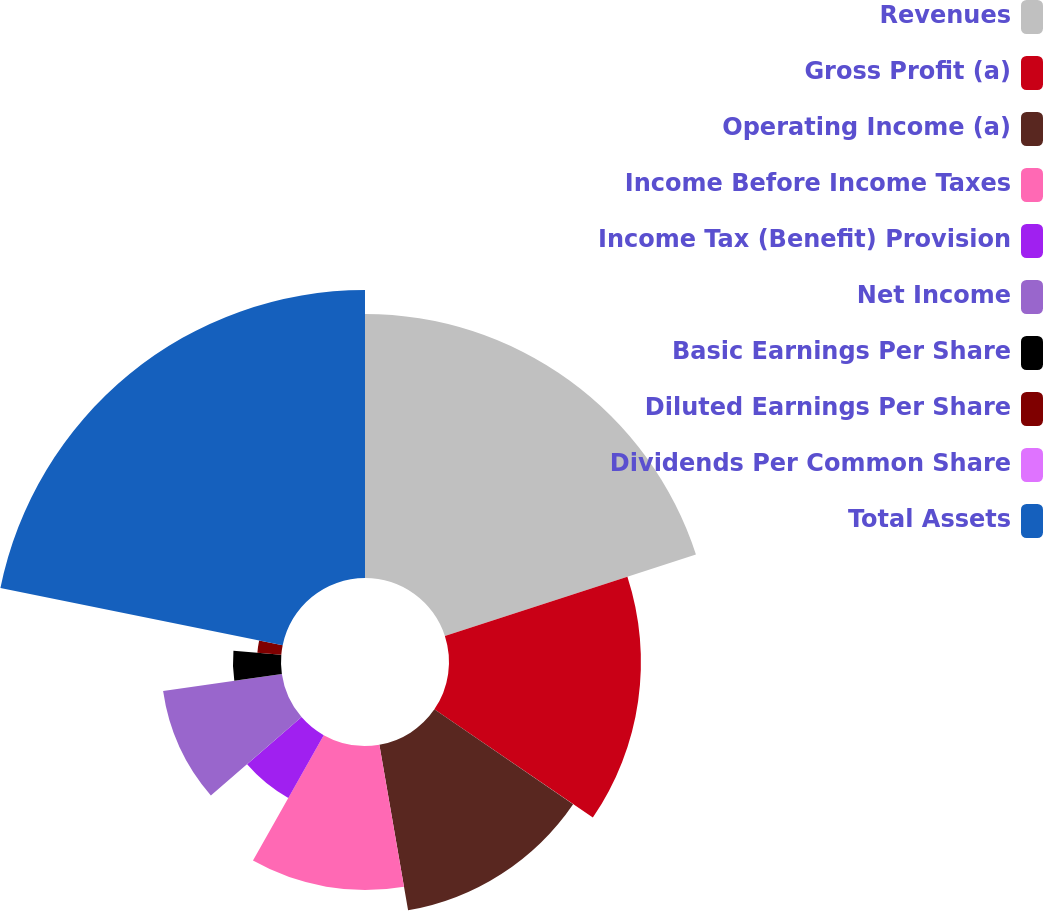<chart> <loc_0><loc_0><loc_500><loc_500><pie_chart><fcel>Revenues<fcel>Gross Profit (a)<fcel>Operating Income (a)<fcel>Income Before Income Taxes<fcel>Income Tax (Benefit) Provision<fcel>Net Income<fcel>Basic Earnings Per Share<fcel>Diluted Earnings Per Share<fcel>Dividends Per Common Share<fcel>Total Assets<nl><fcel>20.0%<fcel>14.54%<fcel>12.73%<fcel>10.91%<fcel>5.46%<fcel>9.09%<fcel>3.64%<fcel>1.82%<fcel>0.0%<fcel>21.82%<nl></chart> 